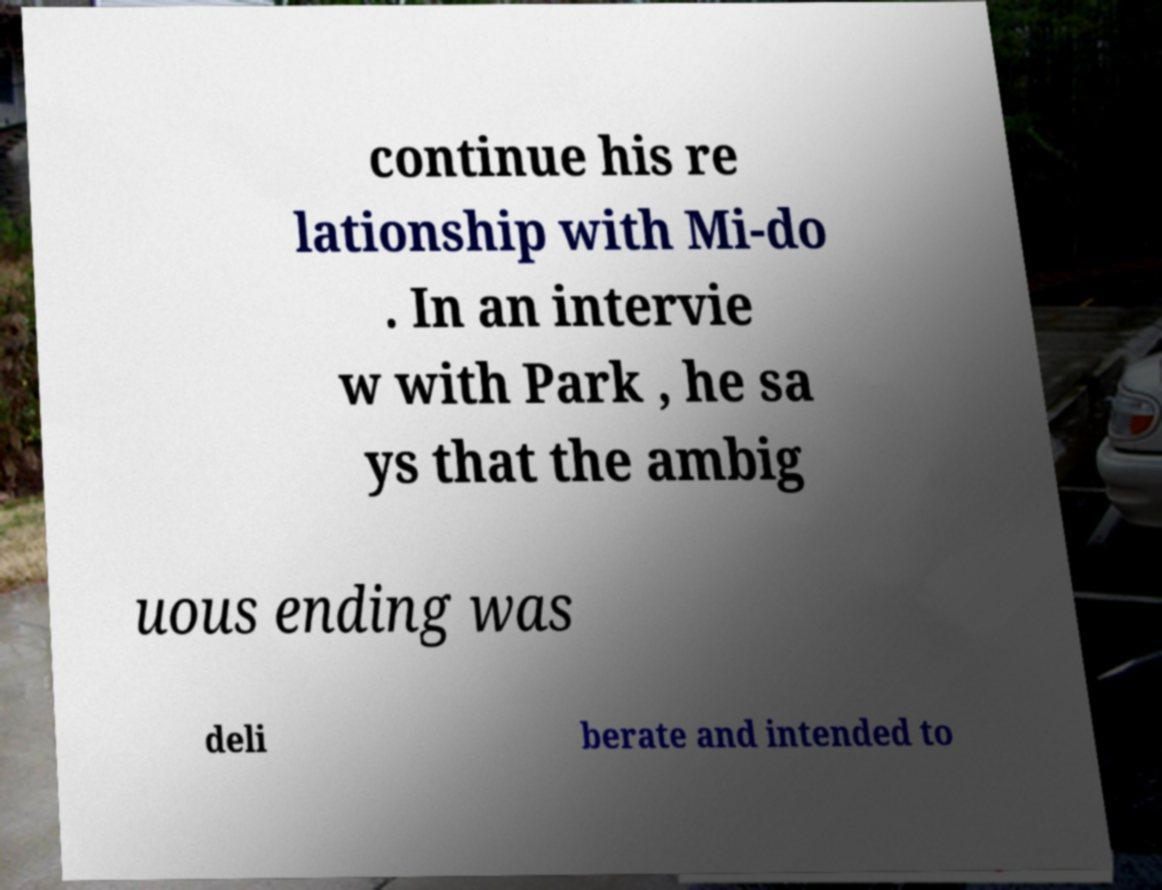For documentation purposes, I need the text within this image transcribed. Could you provide that? continue his re lationship with Mi-do . In an intervie w with Park , he sa ys that the ambig uous ending was deli berate and intended to 